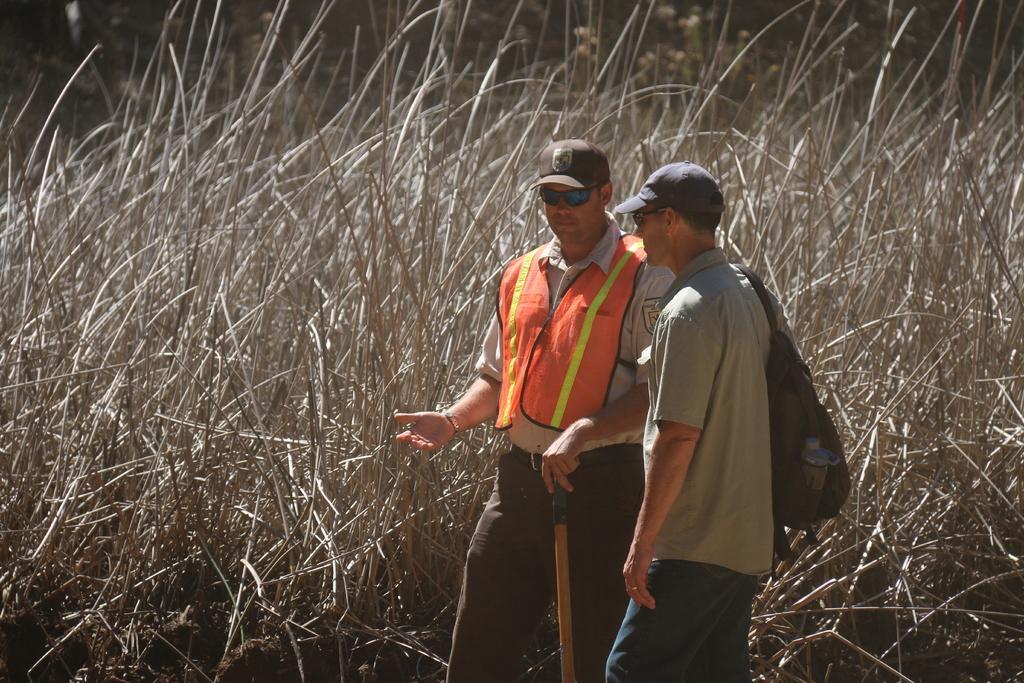Can you describe this image briefly? In this picture I see 2 men in the middle of this picture and I see that they're standing and both of them are wearing caps and the man on the right is wearing a bag and in the background I see the plants. 